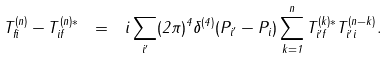Convert formula to latex. <formula><loc_0><loc_0><loc_500><loc_500>T _ { f i } ^ { ( n ) } - T _ { i f } ^ { ( n ) * } \ = \ i \sum _ { i ^ { \prime } } ( 2 \pi ) ^ { 4 } \delta ^ { ( 4 ) } ( P _ { i ^ { \prime } } - P _ { i } ) \sum _ { k = 1 } ^ { n } T _ { i ^ { \prime } f } ^ { ( k ) * } T _ { i ^ { \prime } i } ^ { ( n - k ) } .</formula> 